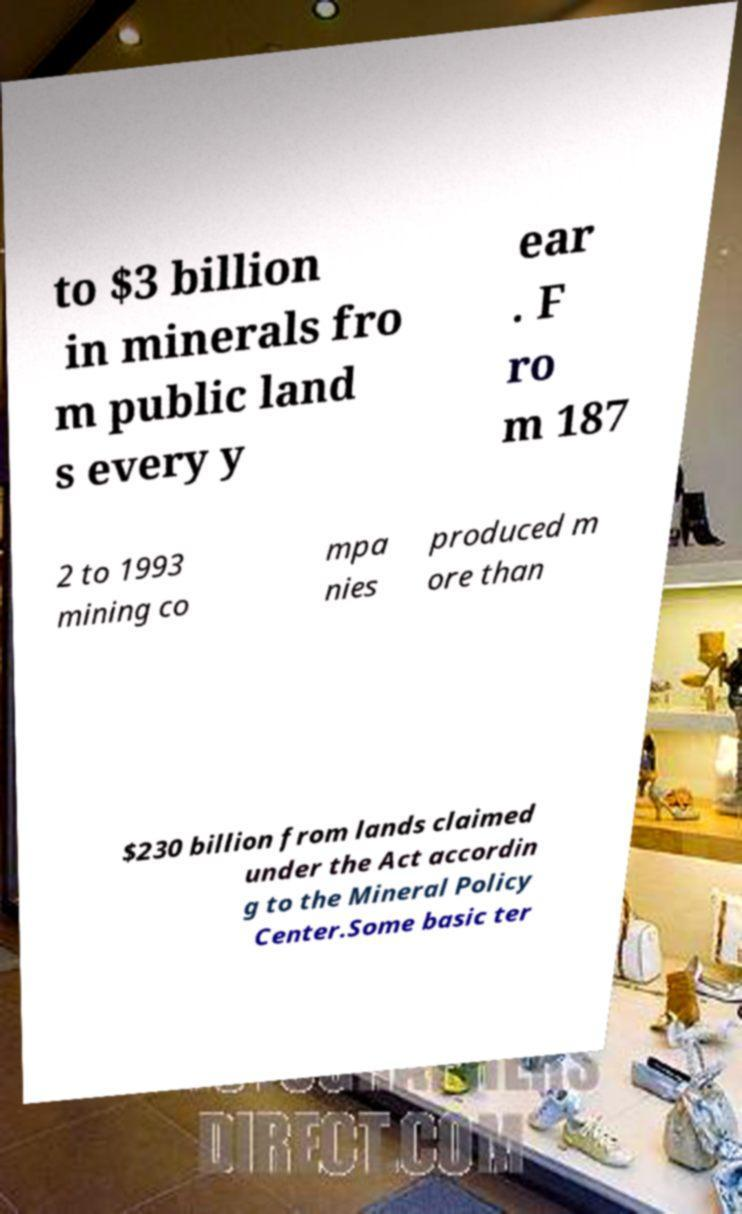Could you assist in decoding the text presented in this image and type it out clearly? to $3 billion in minerals fro m public land s every y ear . F ro m 187 2 to 1993 mining co mpa nies produced m ore than $230 billion from lands claimed under the Act accordin g to the Mineral Policy Center.Some basic ter 